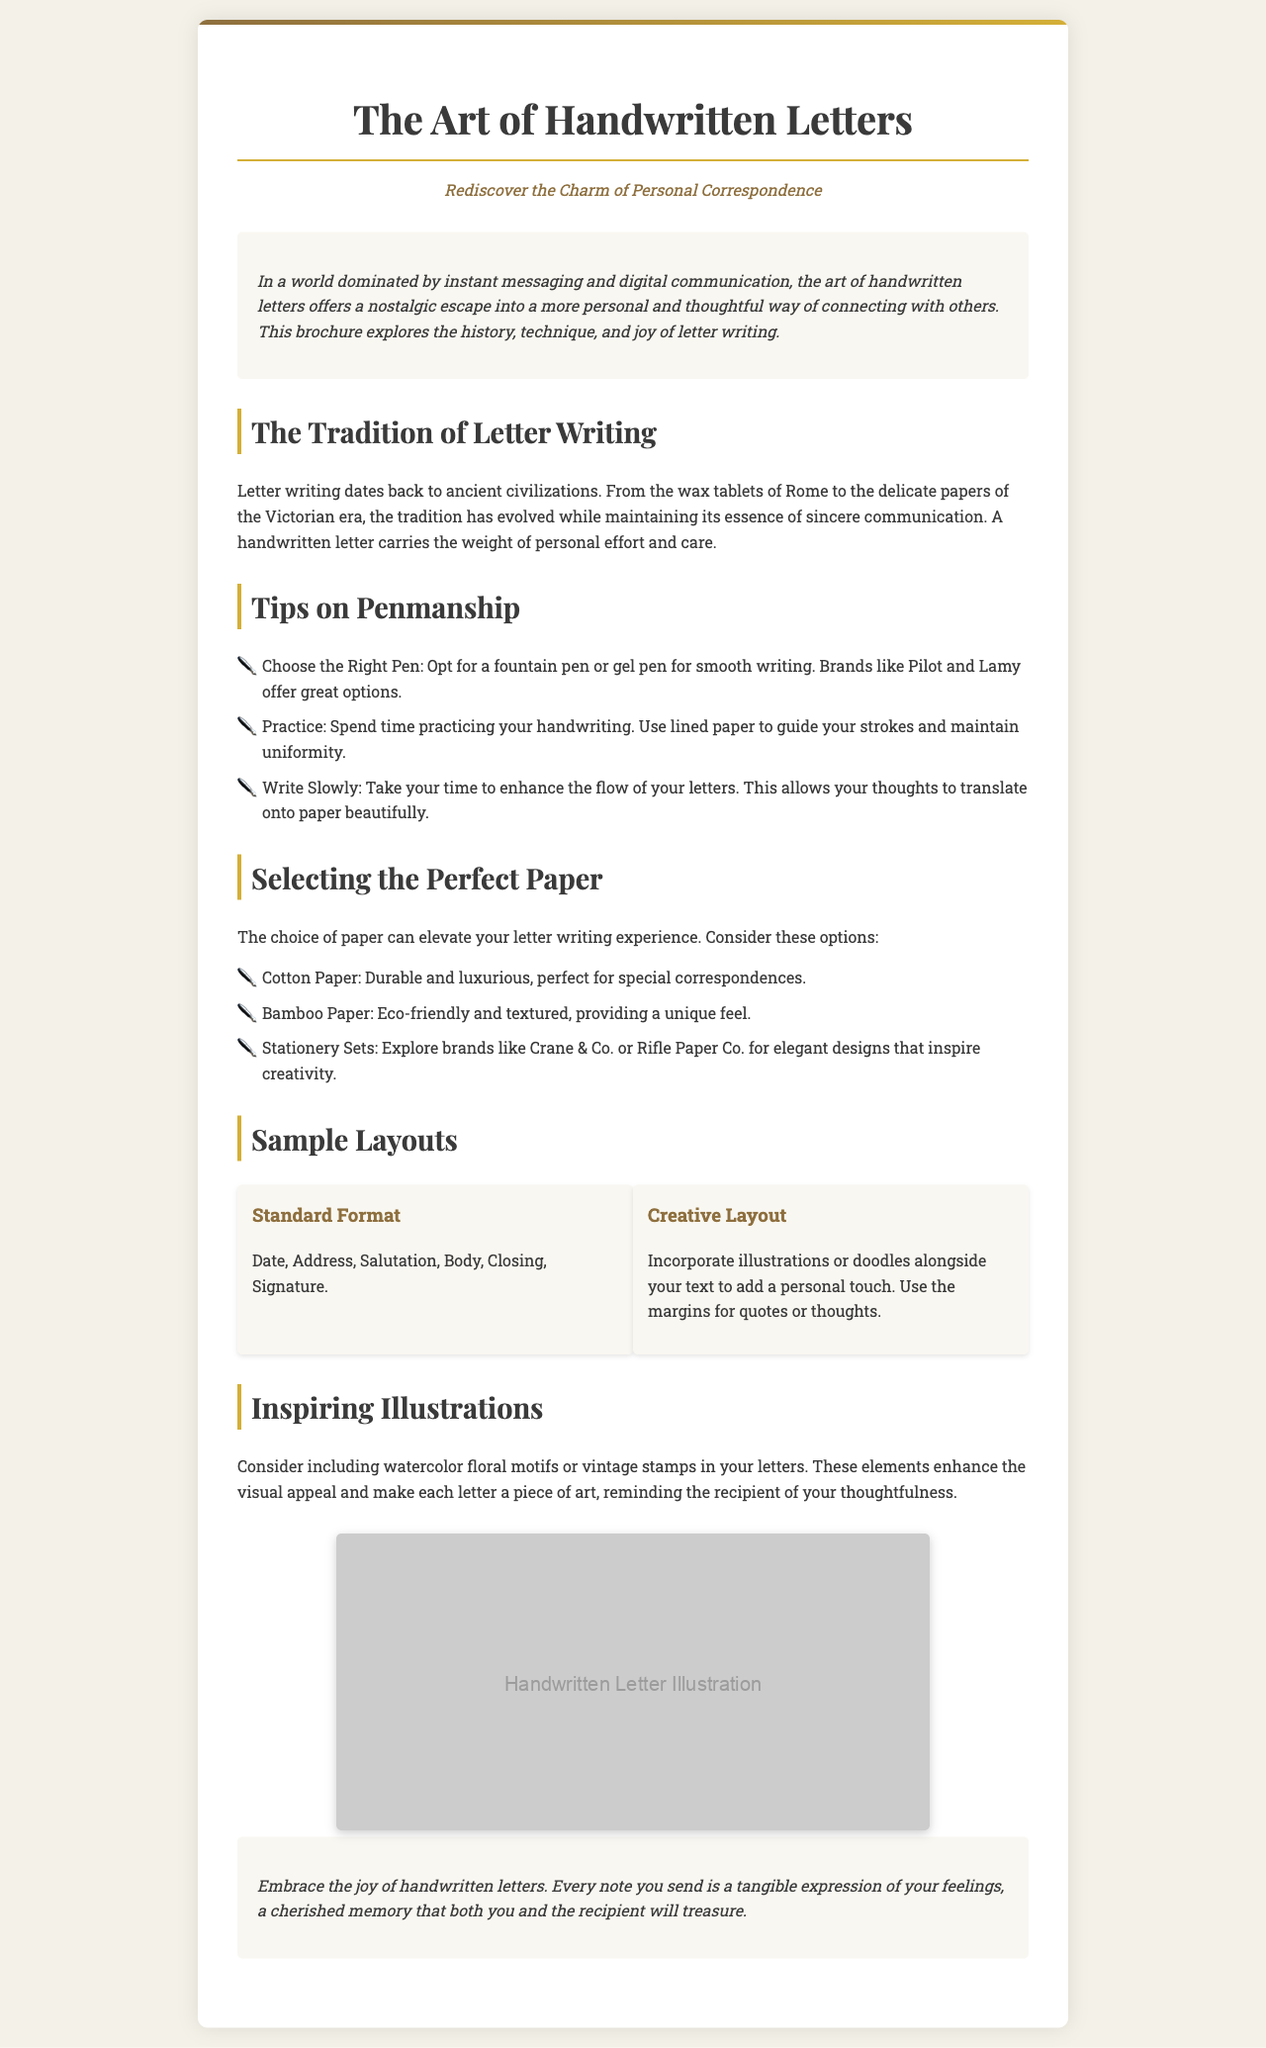What is the title of the brochure? The title prominently displayed at the top of the document is the main subject of the brochure.
Answer: The Art of Handwritten Letters What is the tagline of the brochure? The tagline summarizes the essence of the brochure in a catchy phrase located just below the title.
Answer: Rediscover the Charm of Personal Correspondence What type of writing implement is recommended for smooth writing? The document specifically mentions a type of pen that provides a good writing experience, which is related to penmanship tips.
Answer: Fountain pen Which paper type is described as eco-friendly? The brochure contains a list of paper options, identifying one that is environmentally conscious, appealing to sustainability.
Answer: Bamboo Paper What are the key components of the standard letter format? The brochure lists essential elements in the structure of a letter layout, summarizing standard practices in letter writing.
Answer: Date, Address, Salutation, Body, Closing, Signature What is one way to enhance personal letters? The brochure suggests adding specific artistic elements to letters for a creative touch, which relates to inspiring illustrations section.
Answer: Watercolor floral motifs Which brands are mentioned for stationery selection? The document references particular brands that offer stationery, advising readers on where to find quality options.
Answer: Crane & Co., Rifle Paper Co How is letter writing described in the introduction? The introduction provides a characterization of letter writing as a practice, reflecting on its impact in a modern context.
Answer: Nostalgic escape What does the conclusion encourage readers to do? The concluding remarks of the brochure aim to inspire readers to take a specific action regarding letter writing.
Answer: Embrace the joy of handwritten letters 